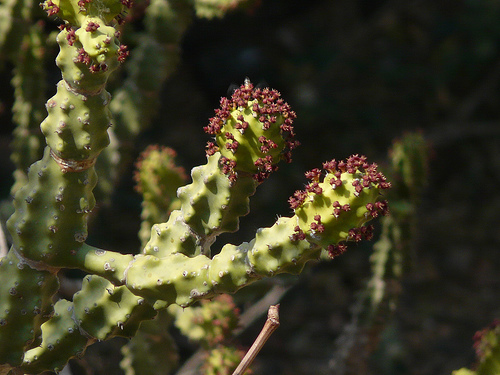<image>
Is the bud on the stem? No. The bud is not positioned on the stem. They may be near each other, but the bud is not supported by or resting on top of the stem. 